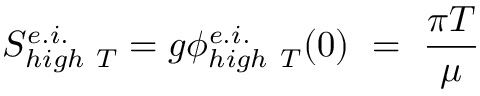<formula> <loc_0><loc_0><loc_500><loc_500>S _ { h i g h T } ^ { e . i . } = g \phi _ { h i g h T } ^ { e . i . } ( 0 ) = \frac { \pi T } { \mu }</formula> 